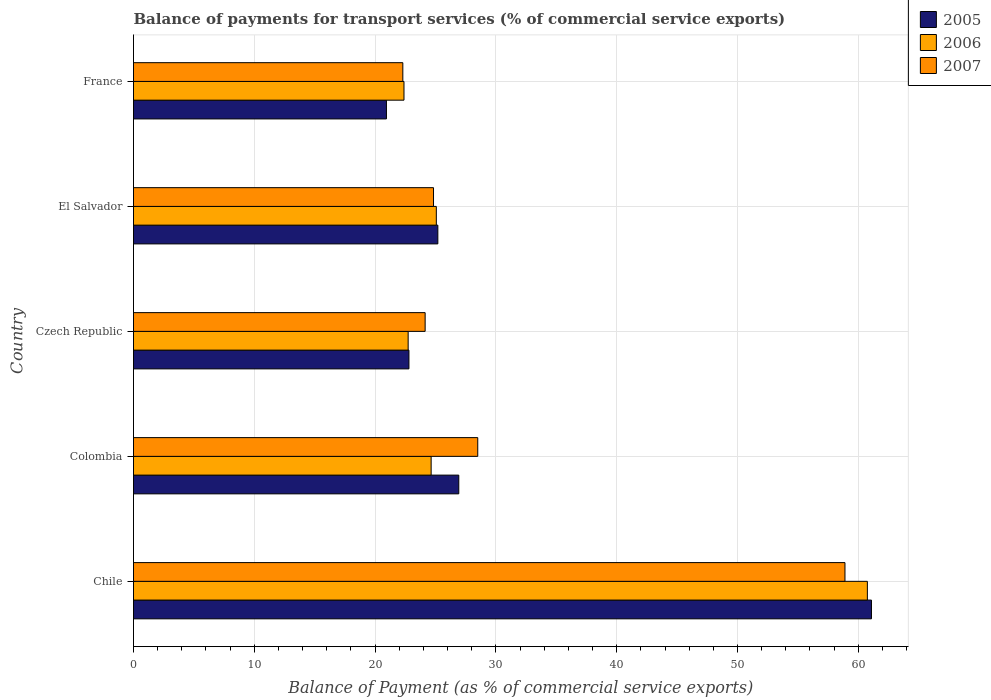How many groups of bars are there?
Your answer should be very brief. 5. Are the number of bars per tick equal to the number of legend labels?
Give a very brief answer. Yes. How many bars are there on the 3rd tick from the top?
Keep it short and to the point. 3. In how many cases, is the number of bars for a given country not equal to the number of legend labels?
Keep it short and to the point. 0. What is the balance of payments for transport services in 2006 in Chile?
Keep it short and to the point. 60.75. Across all countries, what is the maximum balance of payments for transport services in 2006?
Keep it short and to the point. 60.75. Across all countries, what is the minimum balance of payments for transport services in 2006?
Your answer should be compact. 22.39. In which country was the balance of payments for transport services in 2006 maximum?
Offer a terse response. Chile. In which country was the balance of payments for transport services in 2006 minimum?
Make the answer very short. France. What is the total balance of payments for transport services in 2005 in the graph?
Your answer should be very brief. 156.95. What is the difference between the balance of payments for transport services in 2005 in Colombia and that in Czech Republic?
Ensure brevity in your answer.  4.13. What is the difference between the balance of payments for transport services in 2006 in France and the balance of payments for transport services in 2007 in Colombia?
Keep it short and to the point. -6.11. What is the average balance of payments for transport services in 2006 per country?
Ensure brevity in your answer.  31.12. What is the difference between the balance of payments for transport services in 2006 and balance of payments for transport services in 2007 in France?
Make the answer very short. 0.1. In how many countries, is the balance of payments for transport services in 2006 greater than 34 %?
Offer a very short reply. 1. What is the ratio of the balance of payments for transport services in 2007 in Chile to that in Czech Republic?
Keep it short and to the point. 2.44. Is the difference between the balance of payments for transport services in 2006 in Colombia and El Salvador greater than the difference between the balance of payments for transport services in 2007 in Colombia and El Salvador?
Ensure brevity in your answer.  No. What is the difference between the highest and the second highest balance of payments for transport services in 2006?
Provide a succinct answer. 35.68. What is the difference between the highest and the lowest balance of payments for transport services in 2005?
Your response must be concise. 40.15. In how many countries, is the balance of payments for transport services in 2007 greater than the average balance of payments for transport services in 2007 taken over all countries?
Make the answer very short. 1. Is the sum of the balance of payments for transport services in 2006 in Chile and Colombia greater than the maximum balance of payments for transport services in 2007 across all countries?
Provide a succinct answer. Yes. Are all the bars in the graph horizontal?
Offer a very short reply. Yes. Are the values on the major ticks of X-axis written in scientific E-notation?
Offer a terse response. No. Does the graph contain any zero values?
Your answer should be very brief. No. How many legend labels are there?
Make the answer very short. 3. How are the legend labels stacked?
Offer a terse response. Vertical. What is the title of the graph?
Give a very brief answer. Balance of payments for transport services (% of commercial service exports). What is the label or title of the X-axis?
Make the answer very short. Balance of Payment (as % of commercial service exports). What is the Balance of Payment (as % of commercial service exports) of 2005 in Chile?
Make the answer very short. 61.09. What is the Balance of Payment (as % of commercial service exports) in 2006 in Chile?
Offer a very short reply. 60.75. What is the Balance of Payment (as % of commercial service exports) in 2007 in Chile?
Provide a succinct answer. 58.9. What is the Balance of Payment (as % of commercial service exports) of 2005 in Colombia?
Your response must be concise. 26.93. What is the Balance of Payment (as % of commercial service exports) of 2006 in Colombia?
Make the answer very short. 24.64. What is the Balance of Payment (as % of commercial service exports) of 2007 in Colombia?
Provide a succinct answer. 28.5. What is the Balance of Payment (as % of commercial service exports) in 2005 in Czech Republic?
Make the answer very short. 22.8. What is the Balance of Payment (as % of commercial service exports) of 2006 in Czech Republic?
Make the answer very short. 22.74. What is the Balance of Payment (as % of commercial service exports) in 2007 in Czech Republic?
Your response must be concise. 24.14. What is the Balance of Payment (as % of commercial service exports) in 2005 in El Salvador?
Ensure brevity in your answer.  25.19. What is the Balance of Payment (as % of commercial service exports) of 2006 in El Salvador?
Your answer should be compact. 25.07. What is the Balance of Payment (as % of commercial service exports) of 2007 in El Salvador?
Make the answer very short. 24.84. What is the Balance of Payment (as % of commercial service exports) of 2005 in France?
Ensure brevity in your answer.  20.94. What is the Balance of Payment (as % of commercial service exports) in 2006 in France?
Ensure brevity in your answer.  22.39. What is the Balance of Payment (as % of commercial service exports) in 2007 in France?
Make the answer very short. 22.29. Across all countries, what is the maximum Balance of Payment (as % of commercial service exports) of 2005?
Give a very brief answer. 61.09. Across all countries, what is the maximum Balance of Payment (as % of commercial service exports) in 2006?
Keep it short and to the point. 60.75. Across all countries, what is the maximum Balance of Payment (as % of commercial service exports) of 2007?
Your response must be concise. 58.9. Across all countries, what is the minimum Balance of Payment (as % of commercial service exports) in 2005?
Give a very brief answer. 20.94. Across all countries, what is the minimum Balance of Payment (as % of commercial service exports) in 2006?
Keep it short and to the point. 22.39. Across all countries, what is the minimum Balance of Payment (as % of commercial service exports) in 2007?
Make the answer very short. 22.29. What is the total Balance of Payment (as % of commercial service exports) in 2005 in the graph?
Your response must be concise. 156.95. What is the total Balance of Payment (as % of commercial service exports) of 2006 in the graph?
Give a very brief answer. 155.59. What is the total Balance of Payment (as % of commercial service exports) in 2007 in the graph?
Your answer should be very brief. 158.67. What is the difference between the Balance of Payment (as % of commercial service exports) of 2005 in Chile and that in Colombia?
Offer a very short reply. 34.16. What is the difference between the Balance of Payment (as % of commercial service exports) in 2006 in Chile and that in Colombia?
Your response must be concise. 36.11. What is the difference between the Balance of Payment (as % of commercial service exports) of 2007 in Chile and that in Colombia?
Your answer should be very brief. 30.4. What is the difference between the Balance of Payment (as % of commercial service exports) in 2005 in Chile and that in Czech Republic?
Give a very brief answer. 38.29. What is the difference between the Balance of Payment (as % of commercial service exports) of 2006 in Chile and that in Czech Republic?
Provide a succinct answer. 38.02. What is the difference between the Balance of Payment (as % of commercial service exports) of 2007 in Chile and that in Czech Republic?
Make the answer very short. 34.75. What is the difference between the Balance of Payment (as % of commercial service exports) of 2005 in Chile and that in El Salvador?
Your response must be concise. 35.9. What is the difference between the Balance of Payment (as % of commercial service exports) in 2006 in Chile and that in El Salvador?
Your answer should be very brief. 35.68. What is the difference between the Balance of Payment (as % of commercial service exports) of 2007 in Chile and that in El Salvador?
Provide a succinct answer. 34.06. What is the difference between the Balance of Payment (as % of commercial service exports) in 2005 in Chile and that in France?
Make the answer very short. 40.15. What is the difference between the Balance of Payment (as % of commercial service exports) in 2006 in Chile and that in France?
Your answer should be very brief. 38.36. What is the difference between the Balance of Payment (as % of commercial service exports) of 2007 in Chile and that in France?
Keep it short and to the point. 36.6. What is the difference between the Balance of Payment (as % of commercial service exports) in 2005 in Colombia and that in Czech Republic?
Provide a succinct answer. 4.13. What is the difference between the Balance of Payment (as % of commercial service exports) in 2006 in Colombia and that in Czech Republic?
Offer a terse response. 1.9. What is the difference between the Balance of Payment (as % of commercial service exports) of 2007 in Colombia and that in Czech Republic?
Keep it short and to the point. 4.35. What is the difference between the Balance of Payment (as % of commercial service exports) of 2005 in Colombia and that in El Salvador?
Your answer should be compact. 1.73. What is the difference between the Balance of Payment (as % of commercial service exports) of 2006 in Colombia and that in El Salvador?
Your answer should be very brief. -0.43. What is the difference between the Balance of Payment (as % of commercial service exports) of 2007 in Colombia and that in El Salvador?
Provide a succinct answer. 3.66. What is the difference between the Balance of Payment (as % of commercial service exports) in 2005 in Colombia and that in France?
Offer a very short reply. 5.99. What is the difference between the Balance of Payment (as % of commercial service exports) of 2006 in Colombia and that in France?
Your answer should be very brief. 2.25. What is the difference between the Balance of Payment (as % of commercial service exports) of 2007 in Colombia and that in France?
Give a very brief answer. 6.2. What is the difference between the Balance of Payment (as % of commercial service exports) in 2005 in Czech Republic and that in El Salvador?
Offer a very short reply. -2.39. What is the difference between the Balance of Payment (as % of commercial service exports) in 2006 in Czech Republic and that in El Salvador?
Your answer should be compact. -2.33. What is the difference between the Balance of Payment (as % of commercial service exports) in 2007 in Czech Republic and that in El Salvador?
Ensure brevity in your answer.  -0.69. What is the difference between the Balance of Payment (as % of commercial service exports) in 2005 in Czech Republic and that in France?
Provide a succinct answer. 1.86. What is the difference between the Balance of Payment (as % of commercial service exports) of 2006 in Czech Republic and that in France?
Make the answer very short. 0.35. What is the difference between the Balance of Payment (as % of commercial service exports) of 2007 in Czech Republic and that in France?
Offer a terse response. 1.85. What is the difference between the Balance of Payment (as % of commercial service exports) in 2005 in El Salvador and that in France?
Ensure brevity in your answer.  4.26. What is the difference between the Balance of Payment (as % of commercial service exports) in 2006 in El Salvador and that in France?
Give a very brief answer. 2.68. What is the difference between the Balance of Payment (as % of commercial service exports) of 2007 in El Salvador and that in France?
Provide a short and direct response. 2.54. What is the difference between the Balance of Payment (as % of commercial service exports) in 2005 in Chile and the Balance of Payment (as % of commercial service exports) in 2006 in Colombia?
Give a very brief answer. 36.45. What is the difference between the Balance of Payment (as % of commercial service exports) in 2005 in Chile and the Balance of Payment (as % of commercial service exports) in 2007 in Colombia?
Provide a succinct answer. 32.59. What is the difference between the Balance of Payment (as % of commercial service exports) of 2006 in Chile and the Balance of Payment (as % of commercial service exports) of 2007 in Colombia?
Keep it short and to the point. 32.26. What is the difference between the Balance of Payment (as % of commercial service exports) in 2005 in Chile and the Balance of Payment (as % of commercial service exports) in 2006 in Czech Republic?
Your response must be concise. 38.35. What is the difference between the Balance of Payment (as % of commercial service exports) of 2005 in Chile and the Balance of Payment (as % of commercial service exports) of 2007 in Czech Republic?
Give a very brief answer. 36.95. What is the difference between the Balance of Payment (as % of commercial service exports) in 2006 in Chile and the Balance of Payment (as % of commercial service exports) in 2007 in Czech Republic?
Your answer should be compact. 36.61. What is the difference between the Balance of Payment (as % of commercial service exports) in 2005 in Chile and the Balance of Payment (as % of commercial service exports) in 2006 in El Salvador?
Give a very brief answer. 36.02. What is the difference between the Balance of Payment (as % of commercial service exports) of 2005 in Chile and the Balance of Payment (as % of commercial service exports) of 2007 in El Salvador?
Make the answer very short. 36.25. What is the difference between the Balance of Payment (as % of commercial service exports) in 2006 in Chile and the Balance of Payment (as % of commercial service exports) in 2007 in El Salvador?
Your response must be concise. 35.92. What is the difference between the Balance of Payment (as % of commercial service exports) in 2005 in Chile and the Balance of Payment (as % of commercial service exports) in 2006 in France?
Make the answer very short. 38.7. What is the difference between the Balance of Payment (as % of commercial service exports) of 2005 in Chile and the Balance of Payment (as % of commercial service exports) of 2007 in France?
Your answer should be very brief. 38.8. What is the difference between the Balance of Payment (as % of commercial service exports) of 2006 in Chile and the Balance of Payment (as % of commercial service exports) of 2007 in France?
Offer a terse response. 38.46. What is the difference between the Balance of Payment (as % of commercial service exports) of 2005 in Colombia and the Balance of Payment (as % of commercial service exports) of 2006 in Czech Republic?
Keep it short and to the point. 4.19. What is the difference between the Balance of Payment (as % of commercial service exports) in 2005 in Colombia and the Balance of Payment (as % of commercial service exports) in 2007 in Czech Republic?
Provide a succinct answer. 2.78. What is the difference between the Balance of Payment (as % of commercial service exports) of 2006 in Colombia and the Balance of Payment (as % of commercial service exports) of 2007 in Czech Republic?
Offer a very short reply. 0.5. What is the difference between the Balance of Payment (as % of commercial service exports) in 2005 in Colombia and the Balance of Payment (as % of commercial service exports) in 2006 in El Salvador?
Your answer should be very brief. 1.86. What is the difference between the Balance of Payment (as % of commercial service exports) of 2005 in Colombia and the Balance of Payment (as % of commercial service exports) of 2007 in El Salvador?
Provide a short and direct response. 2.09. What is the difference between the Balance of Payment (as % of commercial service exports) in 2006 in Colombia and the Balance of Payment (as % of commercial service exports) in 2007 in El Salvador?
Your answer should be very brief. -0.2. What is the difference between the Balance of Payment (as % of commercial service exports) of 2005 in Colombia and the Balance of Payment (as % of commercial service exports) of 2006 in France?
Your answer should be compact. 4.54. What is the difference between the Balance of Payment (as % of commercial service exports) in 2005 in Colombia and the Balance of Payment (as % of commercial service exports) in 2007 in France?
Your response must be concise. 4.63. What is the difference between the Balance of Payment (as % of commercial service exports) in 2006 in Colombia and the Balance of Payment (as % of commercial service exports) in 2007 in France?
Give a very brief answer. 2.34. What is the difference between the Balance of Payment (as % of commercial service exports) of 2005 in Czech Republic and the Balance of Payment (as % of commercial service exports) of 2006 in El Salvador?
Offer a terse response. -2.27. What is the difference between the Balance of Payment (as % of commercial service exports) in 2005 in Czech Republic and the Balance of Payment (as % of commercial service exports) in 2007 in El Salvador?
Ensure brevity in your answer.  -2.04. What is the difference between the Balance of Payment (as % of commercial service exports) of 2006 in Czech Republic and the Balance of Payment (as % of commercial service exports) of 2007 in El Salvador?
Keep it short and to the point. -2.1. What is the difference between the Balance of Payment (as % of commercial service exports) of 2005 in Czech Republic and the Balance of Payment (as % of commercial service exports) of 2006 in France?
Provide a short and direct response. 0.41. What is the difference between the Balance of Payment (as % of commercial service exports) of 2005 in Czech Republic and the Balance of Payment (as % of commercial service exports) of 2007 in France?
Your answer should be compact. 0.51. What is the difference between the Balance of Payment (as % of commercial service exports) in 2006 in Czech Republic and the Balance of Payment (as % of commercial service exports) in 2007 in France?
Your answer should be very brief. 0.44. What is the difference between the Balance of Payment (as % of commercial service exports) in 2005 in El Salvador and the Balance of Payment (as % of commercial service exports) in 2006 in France?
Keep it short and to the point. 2.8. What is the difference between the Balance of Payment (as % of commercial service exports) of 2005 in El Salvador and the Balance of Payment (as % of commercial service exports) of 2007 in France?
Provide a short and direct response. 2.9. What is the difference between the Balance of Payment (as % of commercial service exports) in 2006 in El Salvador and the Balance of Payment (as % of commercial service exports) in 2007 in France?
Your answer should be compact. 2.77. What is the average Balance of Payment (as % of commercial service exports) in 2005 per country?
Your answer should be very brief. 31.39. What is the average Balance of Payment (as % of commercial service exports) of 2006 per country?
Give a very brief answer. 31.12. What is the average Balance of Payment (as % of commercial service exports) in 2007 per country?
Give a very brief answer. 31.73. What is the difference between the Balance of Payment (as % of commercial service exports) in 2005 and Balance of Payment (as % of commercial service exports) in 2006 in Chile?
Offer a very short reply. 0.34. What is the difference between the Balance of Payment (as % of commercial service exports) of 2005 and Balance of Payment (as % of commercial service exports) of 2007 in Chile?
Provide a succinct answer. 2.19. What is the difference between the Balance of Payment (as % of commercial service exports) of 2006 and Balance of Payment (as % of commercial service exports) of 2007 in Chile?
Your answer should be compact. 1.85. What is the difference between the Balance of Payment (as % of commercial service exports) in 2005 and Balance of Payment (as % of commercial service exports) in 2006 in Colombia?
Provide a short and direct response. 2.29. What is the difference between the Balance of Payment (as % of commercial service exports) in 2005 and Balance of Payment (as % of commercial service exports) in 2007 in Colombia?
Your response must be concise. -1.57. What is the difference between the Balance of Payment (as % of commercial service exports) of 2006 and Balance of Payment (as % of commercial service exports) of 2007 in Colombia?
Provide a succinct answer. -3.86. What is the difference between the Balance of Payment (as % of commercial service exports) in 2005 and Balance of Payment (as % of commercial service exports) in 2006 in Czech Republic?
Your answer should be compact. 0.06. What is the difference between the Balance of Payment (as % of commercial service exports) in 2005 and Balance of Payment (as % of commercial service exports) in 2007 in Czech Republic?
Provide a succinct answer. -1.34. What is the difference between the Balance of Payment (as % of commercial service exports) of 2006 and Balance of Payment (as % of commercial service exports) of 2007 in Czech Republic?
Offer a terse response. -1.41. What is the difference between the Balance of Payment (as % of commercial service exports) of 2005 and Balance of Payment (as % of commercial service exports) of 2006 in El Salvador?
Provide a succinct answer. 0.13. What is the difference between the Balance of Payment (as % of commercial service exports) of 2005 and Balance of Payment (as % of commercial service exports) of 2007 in El Salvador?
Give a very brief answer. 0.36. What is the difference between the Balance of Payment (as % of commercial service exports) of 2006 and Balance of Payment (as % of commercial service exports) of 2007 in El Salvador?
Provide a succinct answer. 0.23. What is the difference between the Balance of Payment (as % of commercial service exports) of 2005 and Balance of Payment (as % of commercial service exports) of 2006 in France?
Offer a very short reply. -1.45. What is the difference between the Balance of Payment (as % of commercial service exports) in 2005 and Balance of Payment (as % of commercial service exports) in 2007 in France?
Your answer should be very brief. -1.36. What is the difference between the Balance of Payment (as % of commercial service exports) of 2006 and Balance of Payment (as % of commercial service exports) of 2007 in France?
Give a very brief answer. 0.1. What is the ratio of the Balance of Payment (as % of commercial service exports) of 2005 in Chile to that in Colombia?
Offer a terse response. 2.27. What is the ratio of the Balance of Payment (as % of commercial service exports) of 2006 in Chile to that in Colombia?
Your response must be concise. 2.47. What is the ratio of the Balance of Payment (as % of commercial service exports) in 2007 in Chile to that in Colombia?
Offer a very short reply. 2.07. What is the ratio of the Balance of Payment (as % of commercial service exports) in 2005 in Chile to that in Czech Republic?
Offer a terse response. 2.68. What is the ratio of the Balance of Payment (as % of commercial service exports) in 2006 in Chile to that in Czech Republic?
Ensure brevity in your answer.  2.67. What is the ratio of the Balance of Payment (as % of commercial service exports) in 2007 in Chile to that in Czech Republic?
Offer a terse response. 2.44. What is the ratio of the Balance of Payment (as % of commercial service exports) of 2005 in Chile to that in El Salvador?
Provide a succinct answer. 2.42. What is the ratio of the Balance of Payment (as % of commercial service exports) of 2006 in Chile to that in El Salvador?
Your answer should be compact. 2.42. What is the ratio of the Balance of Payment (as % of commercial service exports) of 2007 in Chile to that in El Salvador?
Provide a succinct answer. 2.37. What is the ratio of the Balance of Payment (as % of commercial service exports) in 2005 in Chile to that in France?
Ensure brevity in your answer.  2.92. What is the ratio of the Balance of Payment (as % of commercial service exports) in 2006 in Chile to that in France?
Your response must be concise. 2.71. What is the ratio of the Balance of Payment (as % of commercial service exports) of 2007 in Chile to that in France?
Your answer should be very brief. 2.64. What is the ratio of the Balance of Payment (as % of commercial service exports) in 2005 in Colombia to that in Czech Republic?
Keep it short and to the point. 1.18. What is the ratio of the Balance of Payment (as % of commercial service exports) of 2006 in Colombia to that in Czech Republic?
Your response must be concise. 1.08. What is the ratio of the Balance of Payment (as % of commercial service exports) in 2007 in Colombia to that in Czech Republic?
Your response must be concise. 1.18. What is the ratio of the Balance of Payment (as % of commercial service exports) in 2005 in Colombia to that in El Salvador?
Provide a short and direct response. 1.07. What is the ratio of the Balance of Payment (as % of commercial service exports) in 2006 in Colombia to that in El Salvador?
Give a very brief answer. 0.98. What is the ratio of the Balance of Payment (as % of commercial service exports) in 2007 in Colombia to that in El Salvador?
Provide a short and direct response. 1.15. What is the ratio of the Balance of Payment (as % of commercial service exports) in 2005 in Colombia to that in France?
Make the answer very short. 1.29. What is the ratio of the Balance of Payment (as % of commercial service exports) in 2006 in Colombia to that in France?
Your answer should be very brief. 1.1. What is the ratio of the Balance of Payment (as % of commercial service exports) in 2007 in Colombia to that in France?
Offer a terse response. 1.28. What is the ratio of the Balance of Payment (as % of commercial service exports) in 2005 in Czech Republic to that in El Salvador?
Offer a terse response. 0.91. What is the ratio of the Balance of Payment (as % of commercial service exports) of 2006 in Czech Republic to that in El Salvador?
Your answer should be compact. 0.91. What is the ratio of the Balance of Payment (as % of commercial service exports) in 2007 in Czech Republic to that in El Salvador?
Your answer should be very brief. 0.97. What is the ratio of the Balance of Payment (as % of commercial service exports) in 2005 in Czech Republic to that in France?
Make the answer very short. 1.09. What is the ratio of the Balance of Payment (as % of commercial service exports) in 2006 in Czech Republic to that in France?
Make the answer very short. 1.02. What is the ratio of the Balance of Payment (as % of commercial service exports) in 2007 in Czech Republic to that in France?
Give a very brief answer. 1.08. What is the ratio of the Balance of Payment (as % of commercial service exports) of 2005 in El Salvador to that in France?
Your answer should be very brief. 1.2. What is the ratio of the Balance of Payment (as % of commercial service exports) in 2006 in El Salvador to that in France?
Your answer should be very brief. 1.12. What is the ratio of the Balance of Payment (as % of commercial service exports) of 2007 in El Salvador to that in France?
Give a very brief answer. 1.11. What is the difference between the highest and the second highest Balance of Payment (as % of commercial service exports) of 2005?
Give a very brief answer. 34.16. What is the difference between the highest and the second highest Balance of Payment (as % of commercial service exports) of 2006?
Ensure brevity in your answer.  35.68. What is the difference between the highest and the second highest Balance of Payment (as % of commercial service exports) of 2007?
Offer a very short reply. 30.4. What is the difference between the highest and the lowest Balance of Payment (as % of commercial service exports) in 2005?
Keep it short and to the point. 40.15. What is the difference between the highest and the lowest Balance of Payment (as % of commercial service exports) in 2006?
Your answer should be very brief. 38.36. What is the difference between the highest and the lowest Balance of Payment (as % of commercial service exports) of 2007?
Give a very brief answer. 36.6. 